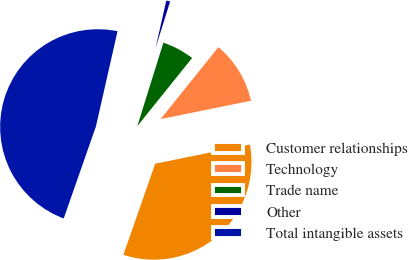<chart> <loc_0><loc_0><loc_500><loc_500><pie_chart><fcel>Customer relationships<fcel>Technology<fcel>Trade name<fcel>Other<fcel>Total intangible assets<nl><fcel>33.54%<fcel>11.04%<fcel>5.96%<fcel>1.27%<fcel>48.19%<nl></chart> 